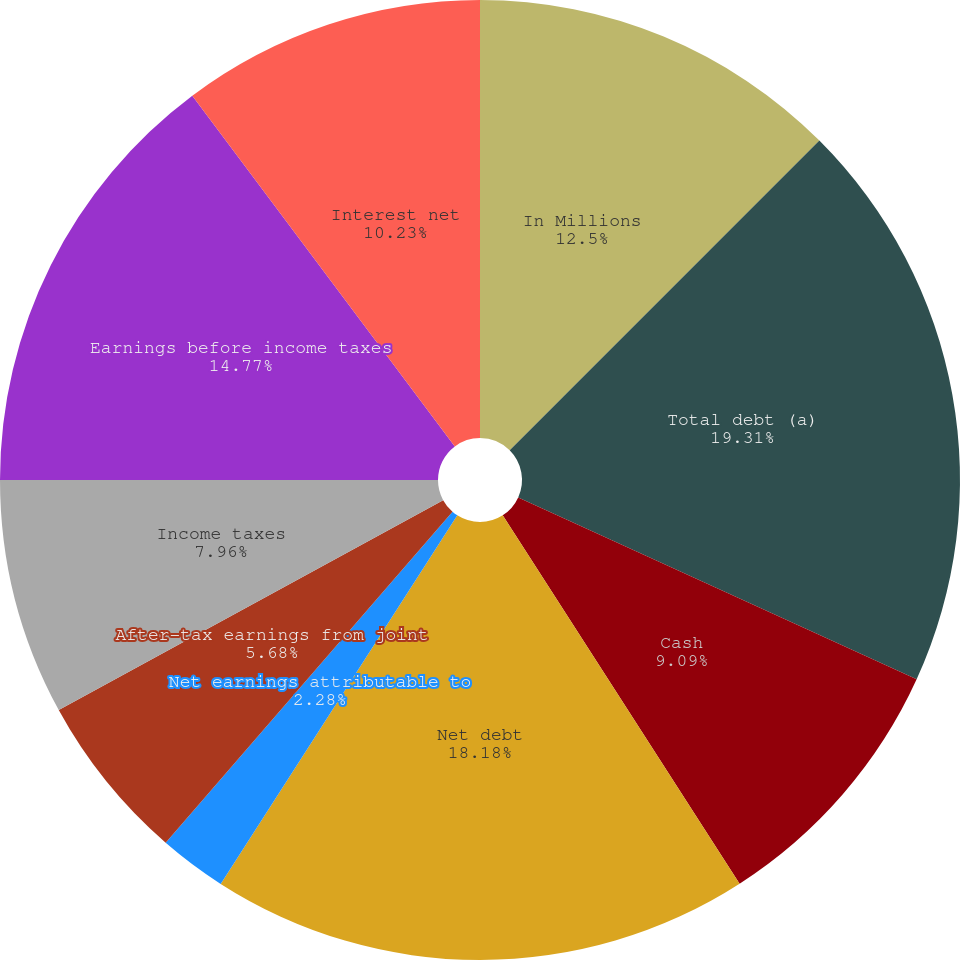<chart> <loc_0><loc_0><loc_500><loc_500><pie_chart><fcel>In Millions<fcel>Total debt (a)<fcel>Cash<fcel>Net debt<fcel>Net earnings attributable to<fcel>After-tax earnings from joint<fcel>Income taxes<fcel>Earnings before income taxes<fcel>Interest net<nl><fcel>12.5%<fcel>19.32%<fcel>9.09%<fcel>18.18%<fcel>2.28%<fcel>5.68%<fcel>7.96%<fcel>14.77%<fcel>10.23%<nl></chart> 